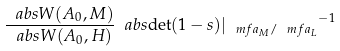Convert formula to latex. <formula><loc_0><loc_0><loc_500><loc_500>\frac { \ a b s { W ( A _ { 0 } , M ) } } { \ a b s { W ( A _ { 0 } , H ) } } \ a b s { \det ( 1 - s ) | _ { \ m f { a } _ { M } / \ m f { a } _ { L } } } ^ { - 1 }</formula> 